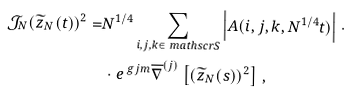<formula> <loc_0><loc_0><loc_500><loc_500>\mathcal { J } _ { N } ( \widetilde { z } _ { N } ( t ) ) ^ { 2 } = & N ^ { 1 / 4 } \sum _ { i , j , k \in \ m a t h s c r { S } } \left | A ( i , j , k , N ^ { 1 / 4 } t ) \right | \, \cdot \\ & \, \cdot e ^ { \ g j m } \overline { \nabla } ^ { ( j ) } \left [ ( \widetilde { z } _ { N } ( s ) ) ^ { 2 } \right ] \, ,</formula> 